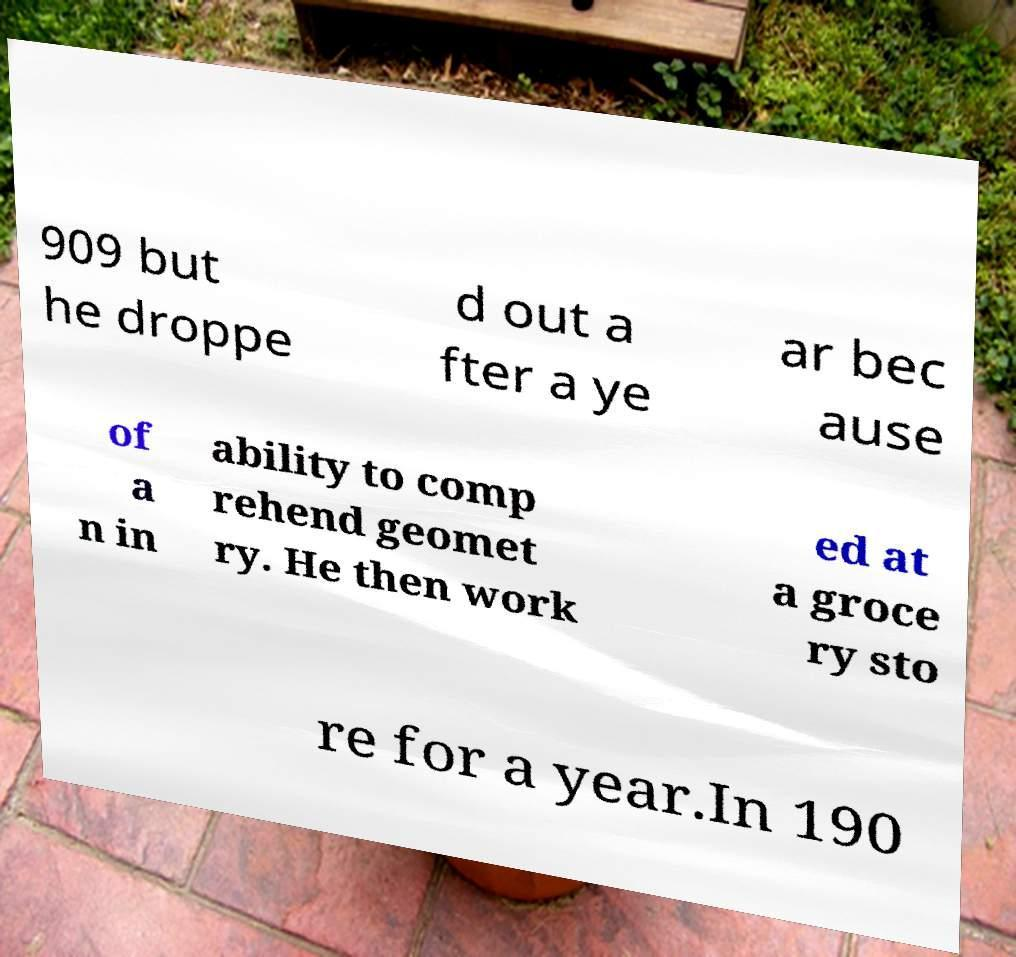Could you extract and type out the text from this image? 909 but he droppe d out a fter a ye ar bec ause of a n in ability to comp rehend geomet ry. He then work ed at a groce ry sto re for a year.In 190 